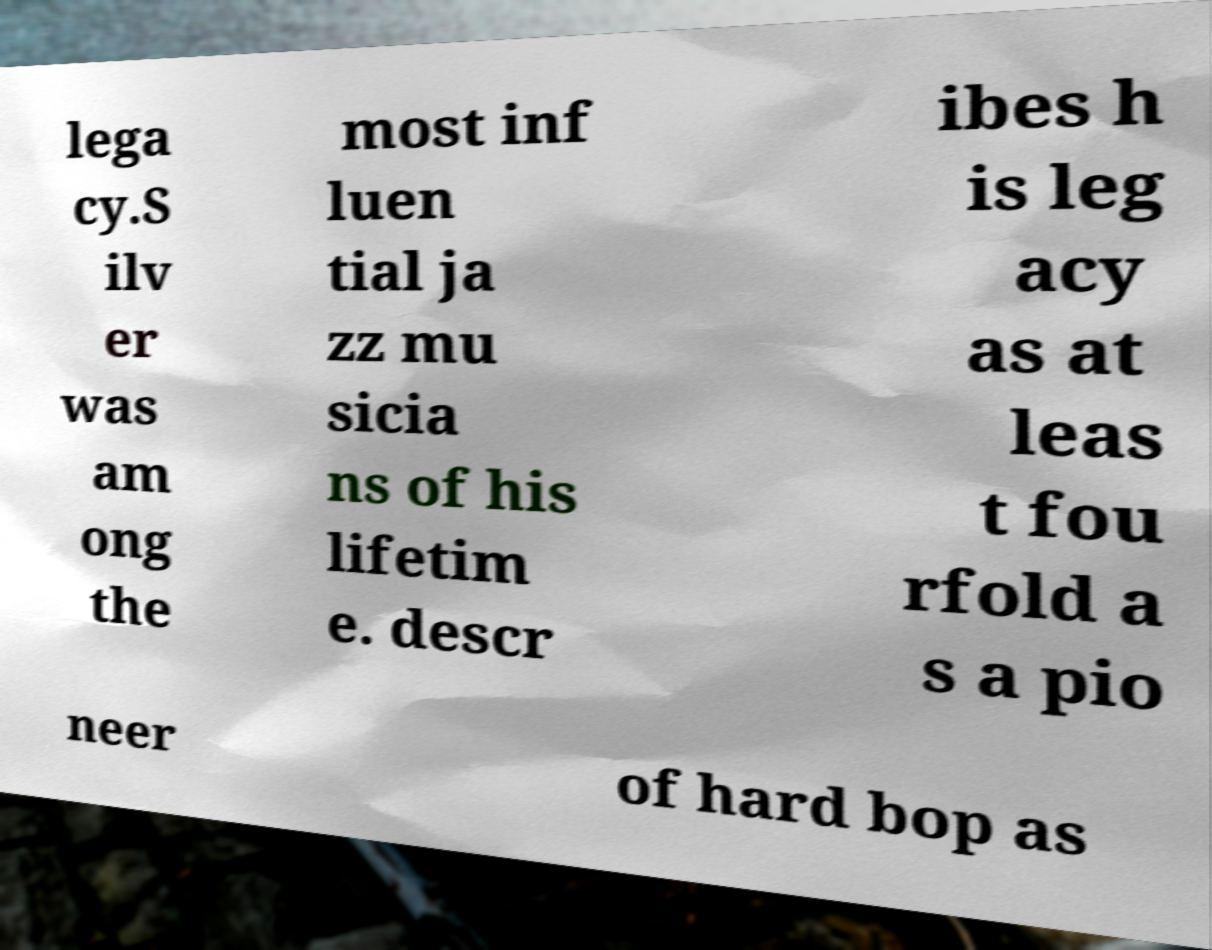I need the written content from this picture converted into text. Can you do that? lega cy.S ilv er was am ong the most inf luen tial ja zz mu sicia ns of his lifetim e. descr ibes h is leg acy as at leas t fou rfold a s a pio neer of hard bop as 